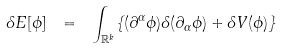Convert formula to latex. <formula><loc_0><loc_0><loc_500><loc_500>\delta E [ \phi ] \ = \ \int _ { \mathbb { R } ^ { k } } \{ ( \partial ^ { \alpha } \phi ) \delta ( \partial _ { \alpha } \phi ) + \delta V ( \phi ) \}</formula> 